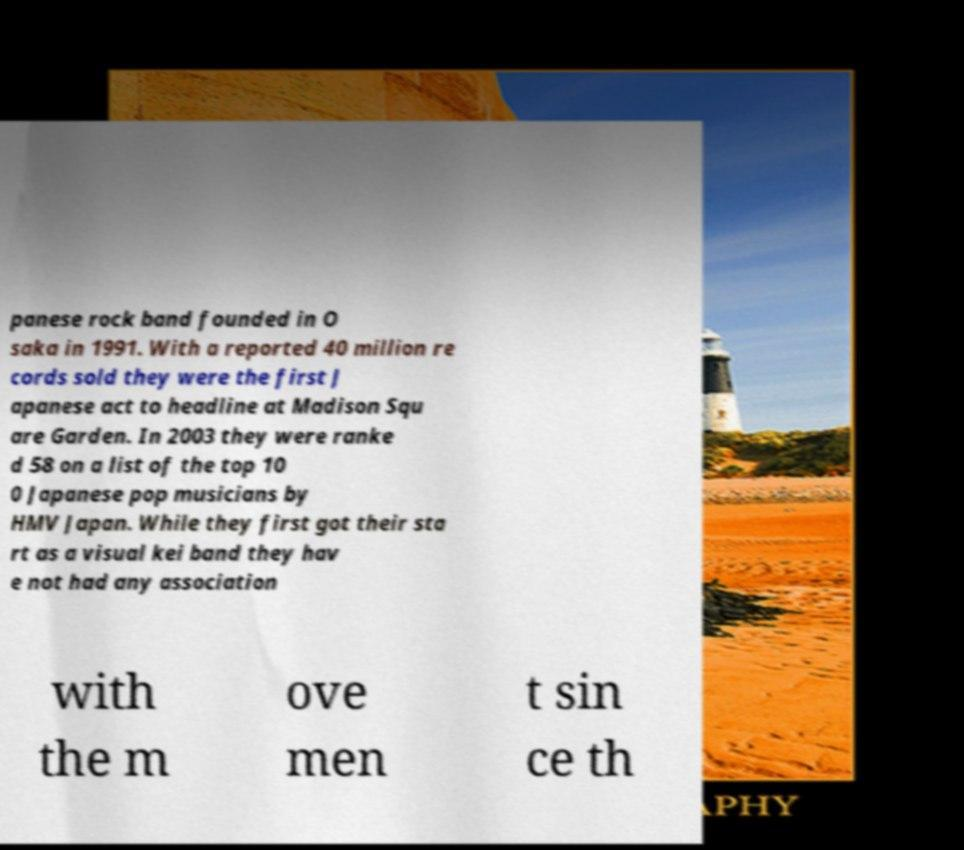For documentation purposes, I need the text within this image transcribed. Could you provide that? panese rock band founded in O saka in 1991. With a reported 40 million re cords sold they were the first J apanese act to headline at Madison Squ are Garden. In 2003 they were ranke d 58 on a list of the top 10 0 Japanese pop musicians by HMV Japan. While they first got their sta rt as a visual kei band they hav e not had any association with the m ove men t sin ce th 